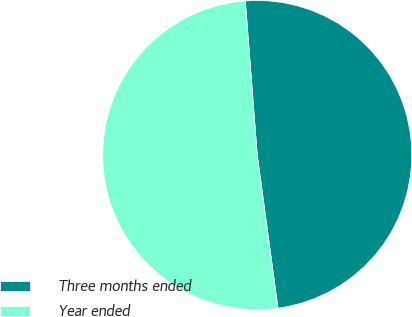<chart> <loc_0><loc_0><loc_500><loc_500><pie_chart><fcel>Three months ended<fcel>Year ended<nl><fcel>49.09%<fcel>50.91%<nl></chart> 